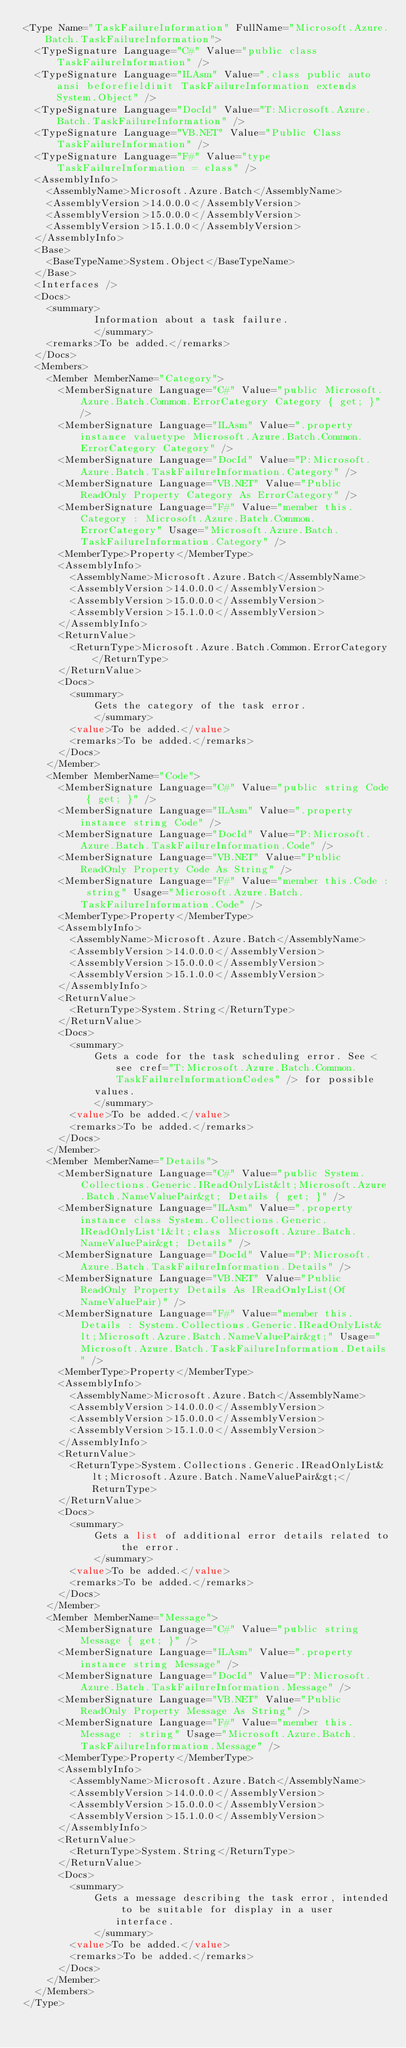<code> <loc_0><loc_0><loc_500><loc_500><_XML_><Type Name="TaskFailureInformation" FullName="Microsoft.Azure.Batch.TaskFailureInformation">
  <TypeSignature Language="C#" Value="public class TaskFailureInformation" />
  <TypeSignature Language="ILAsm" Value=".class public auto ansi beforefieldinit TaskFailureInformation extends System.Object" />
  <TypeSignature Language="DocId" Value="T:Microsoft.Azure.Batch.TaskFailureInformation" />
  <TypeSignature Language="VB.NET" Value="Public Class TaskFailureInformation" />
  <TypeSignature Language="F#" Value="type TaskFailureInformation = class" />
  <AssemblyInfo>
    <AssemblyName>Microsoft.Azure.Batch</AssemblyName>
    <AssemblyVersion>14.0.0.0</AssemblyVersion>
    <AssemblyVersion>15.0.0.0</AssemblyVersion>
    <AssemblyVersion>15.1.0.0</AssemblyVersion>
  </AssemblyInfo>
  <Base>
    <BaseTypeName>System.Object</BaseTypeName>
  </Base>
  <Interfaces />
  <Docs>
    <summary>
            Information about a task failure.
            </summary>
    <remarks>To be added.</remarks>
  </Docs>
  <Members>
    <Member MemberName="Category">
      <MemberSignature Language="C#" Value="public Microsoft.Azure.Batch.Common.ErrorCategory Category { get; }" />
      <MemberSignature Language="ILAsm" Value=".property instance valuetype Microsoft.Azure.Batch.Common.ErrorCategory Category" />
      <MemberSignature Language="DocId" Value="P:Microsoft.Azure.Batch.TaskFailureInformation.Category" />
      <MemberSignature Language="VB.NET" Value="Public ReadOnly Property Category As ErrorCategory" />
      <MemberSignature Language="F#" Value="member this.Category : Microsoft.Azure.Batch.Common.ErrorCategory" Usage="Microsoft.Azure.Batch.TaskFailureInformation.Category" />
      <MemberType>Property</MemberType>
      <AssemblyInfo>
        <AssemblyName>Microsoft.Azure.Batch</AssemblyName>
        <AssemblyVersion>14.0.0.0</AssemblyVersion>
        <AssemblyVersion>15.0.0.0</AssemblyVersion>
        <AssemblyVersion>15.1.0.0</AssemblyVersion>
      </AssemblyInfo>
      <ReturnValue>
        <ReturnType>Microsoft.Azure.Batch.Common.ErrorCategory</ReturnType>
      </ReturnValue>
      <Docs>
        <summary>
            Gets the category of the task error.
            </summary>
        <value>To be added.</value>
        <remarks>To be added.</remarks>
      </Docs>
    </Member>
    <Member MemberName="Code">
      <MemberSignature Language="C#" Value="public string Code { get; }" />
      <MemberSignature Language="ILAsm" Value=".property instance string Code" />
      <MemberSignature Language="DocId" Value="P:Microsoft.Azure.Batch.TaskFailureInformation.Code" />
      <MemberSignature Language="VB.NET" Value="Public ReadOnly Property Code As String" />
      <MemberSignature Language="F#" Value="member this.Code : string" Usage="Microsoft.Azure.Batch.TaskFailureInformation.Code" />
      <MemberType>Property</MemberType>
      <AssemblyInfo>
        <AssemblyName>Microsoft.Azure.Batch</AssemblyName>
        <AssemblyVersion>14.0.0.0</AssemblyVersion>
        <AssemblyVersion>15.0.0.0</AssemblyVersion>
        <AssemblyVersion>15.1.0.0</AssemblyVersion>
      </AssemblyInfo>
      <ReturnValue>
        <ReturnType>System.String</ReturnType>
      </ReturnValue>
      <Docs>
        <summary>
            Gets a code for the task scheduling error. See <see cref="T:Microsoft.Azure.Batch.Common.TaskFailureInformationCodes" /> for possible 
            values.
            </summary>
        <value>To be added.</value>
        <remarks>To be added.</remarks>
      </Docs>
    </Member>
    <Member MemberName="Details">
      <MemberSignature Language="C#" Value="public System.Collections.Generic.IReadOnlyList&lt;Microsoft.Azure.Batch.NameValuePair&gt; Details { get; }" />
      <MemberSignature Language="ILAsm" Value=".property instance class System.Collections.Generic.IReadOnlyList`1&lt;class Microsoft.Azure.Batch.NameValuePair&gt; Details" />
      <MemberSignature Language="DocId" Value="P:Microsoft.Azure.Batch.TaskFailureInformation.Details" />
      <MemberSignature Language="VB.NET" Value="Public ReadOnly Property Details As IReadOnlyList(Of NameValuePair)" />
      <MemberSignature Language="F#" Value="member this.Details : System.Collections.Generic.IReadOnlyList&lt;Microsoft.Azure.Batch.NameValuePair&gt;" Usage="Microsoft.Azure.Batch.TaskFailureInformation.Details" />
      <MemberType>Property</MemberType>
      <AssemblyInfo>
        <AssemblyName>Microsoft.Azure.Batch</AssemblyName>
        <AssemblyVersion>14.0.0.0</AssemblyVersion>
        <AssemblyVersion>15.0.0.0</AssemblyVersion>
        <AssemblyVersion>15.1.0.0</AssemblyVersion>
      </AssemblyInfo>
      <ReturnValue>
        <ReturnType>System.Collections.Generic.IReadOnlyList&lt;Microsoft.Azure.Batch.NameValuePair&gt;</ReturnType>
      </ReturnValue>
      <Docs>
        <summary>
            Gets a list of additional error details related to the error.
            </summary>
        <value>To be added.</value>
        <remarks>To be added.</remarks>
      </Docs>
    </Member>
    <Member MemberName="Message">
      <MemberSignature Language="C#" Value="public string Message { get; }" />
      <MemberSignature Language="ILAsm" Value=".property instance string Message" />
      <MemberSignature Language="DocId" Value="P:Microsoft.Azure.Batch.TaskFailureInformation.Message" />
      <MemberSignature Language="VB.NET" Value="Public ReadOnly Property Message As String" />
      <MemberSignature Language="F#" Value="member this.Message : string" Usage="Microsoft.Azure.Batch.TaskFailureInformation.Message" />
      <MemberType>Property</MemberType>
      <AssemblyInfo>
        <AssemblyName>Microsoft.Azure.Batch</AssemblyName>
        <AssemblyVersion>14.0.0.0</AssemblyVersion>
        <AssemblyVersion>15.0.0.0</AssemblyVersion>
        <AssemblyVersion>15.1.0.0</AssemblyVersion>
      </AssemblyInfo>
      <ReturnValue>
        <ReturnType>System.String</ReturnType>
      </ReturnValue>
      <Docs>
        <summary>
            Gets a message describing the task error, intended to be suitable for display in a user interface.
            </summary>
        <value>To be added.</value>
        <remarks>To be added.</remarks>
      </Docs>
    </Member>
  </Members>
</Type>
</code> 